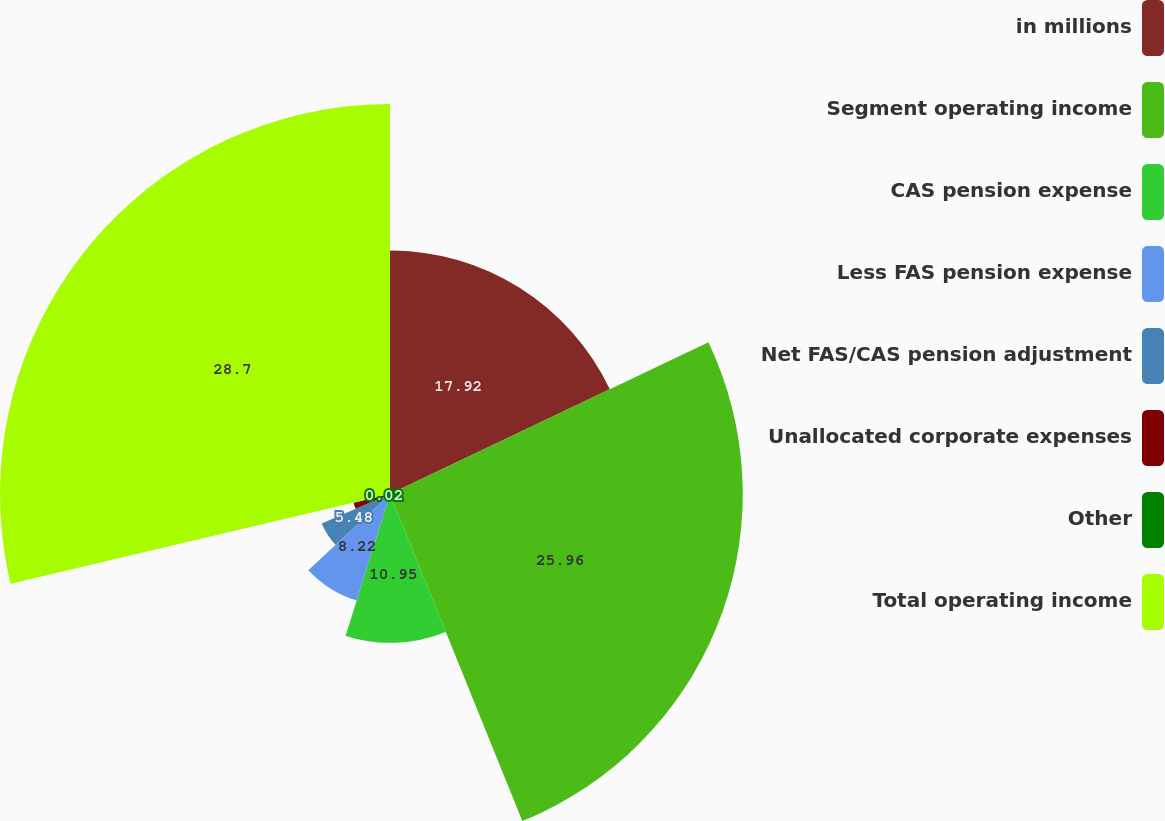<chart> <loc_0><loc_0><loc_500><loc_500><pie_chart><fcel>in millions<fcel>Segment operating income<fcel>CAS pension expense<fcel>Less FAS pension expense<fcel>Net FAS/CAS pension adjustment<fcel>Unallocated corporate expenses<fcel>Other<fcel>Total operating income<nl><fcel>17.92%<fcel>25.96%<fcel>10.95%<fcel>8.22%<fcel>5.48%<fcel>2.75%<fcel>0.02%<fcel>28.7%<nl></chart> 